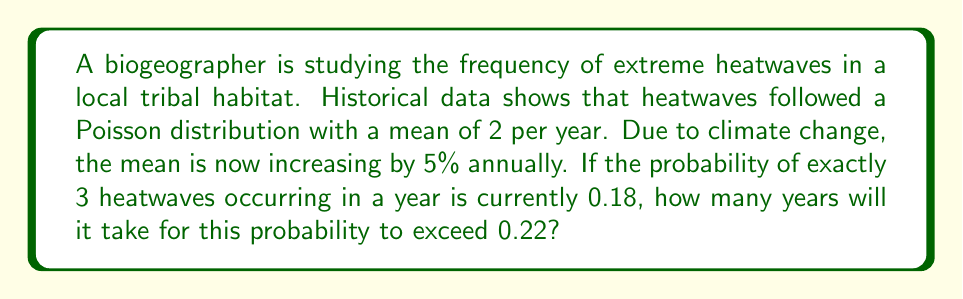Provide a solution to this math problem. Let's approach this step-by-step:

1) The Poisson distribution is given by:

   $$P(X=k) = \frac{\lambda^k e^{-\lambda}}{k!}$$

   where $\lambda$ is the mean and $k$ is the number of occurrences.

2) We're told that $P(X=3) = 0.18$ currently. Let's find the current $\lambda$:

   $$0.18 = \frac{\lambda^3 e^{-\lambda}}{3!}$$

3) Solving this equation numerically (using software or iteration), we get:

   $$\lambda \approx 2.674$$

4) Now, we need to find when $P(X=3)$ will exceed 0.22. Let's call the number of years $n$. After $n$ years, $\lambda$ will be:

   $$\lambda_n = 2.674 \times (1.05)^n$$

5) We need to solve:

   $$0.22 < \frac{(2.674 \times (1.05)^n)^3 e^{-(2.674 \times (1.05)^n)}}{3!}$$

6) Solving this inequality numerically, we find:

   $$n \approx 3.38$$

7) Since we need a whole number of years, we round up to 4.
Answer: 4 years 